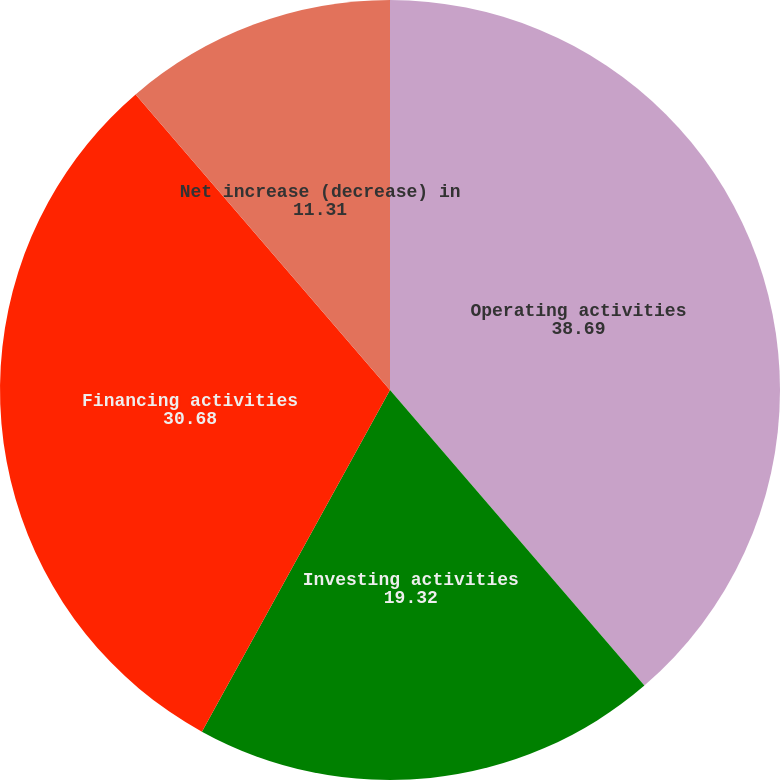Convert chart to OTSL. <chart><loc_0><loc_0><loc_500><loc_500><pie_chart><fcel>Operating activities<fcel>Investing activities<fcel>Financing activities<fcel>Net increase (decrease) in<nl><fcel>38.69%<fcel>19.32%<fcel>30.68%<fcel>11.31%<nl></chart> 